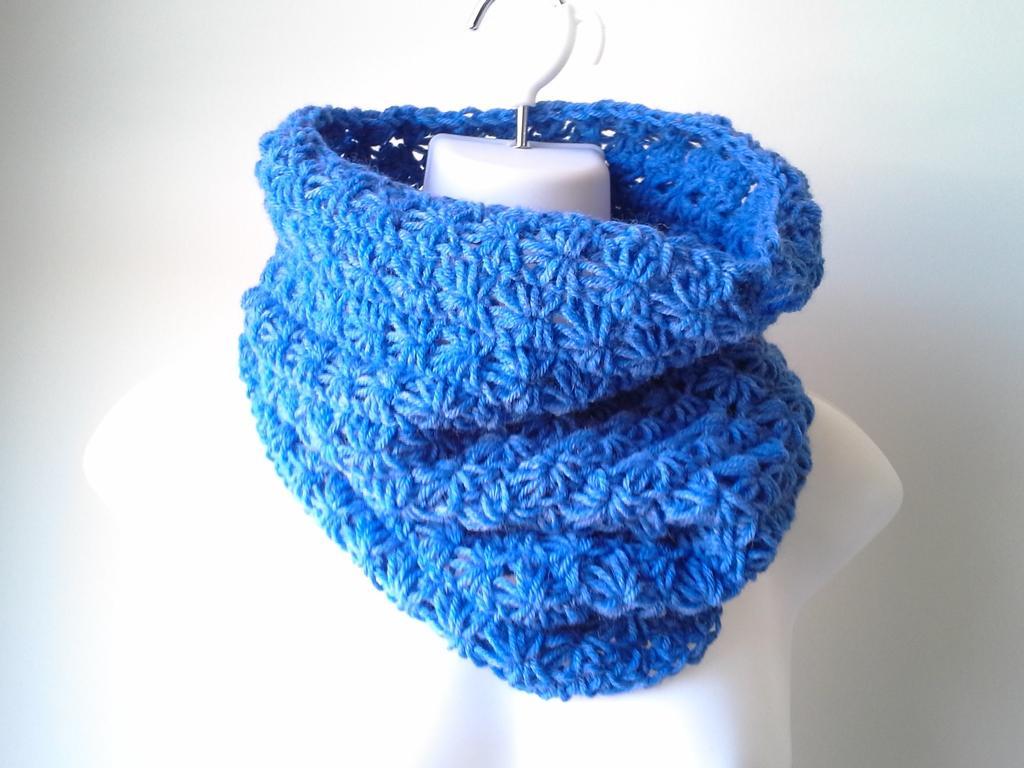Describe this image in one or two sentences. This image consists of a cloth made up of wool. And we can see a hanger in white color. In the background, there is a wall. And the cloth is in blue color. 